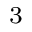Convert formula to latex. <formula><loc_0><loc_0><loc_500><loc_500>_ { 3 }</formula> 